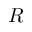<formula> <loc_0><loc_0><loc_500><loc_500>R</formula> 